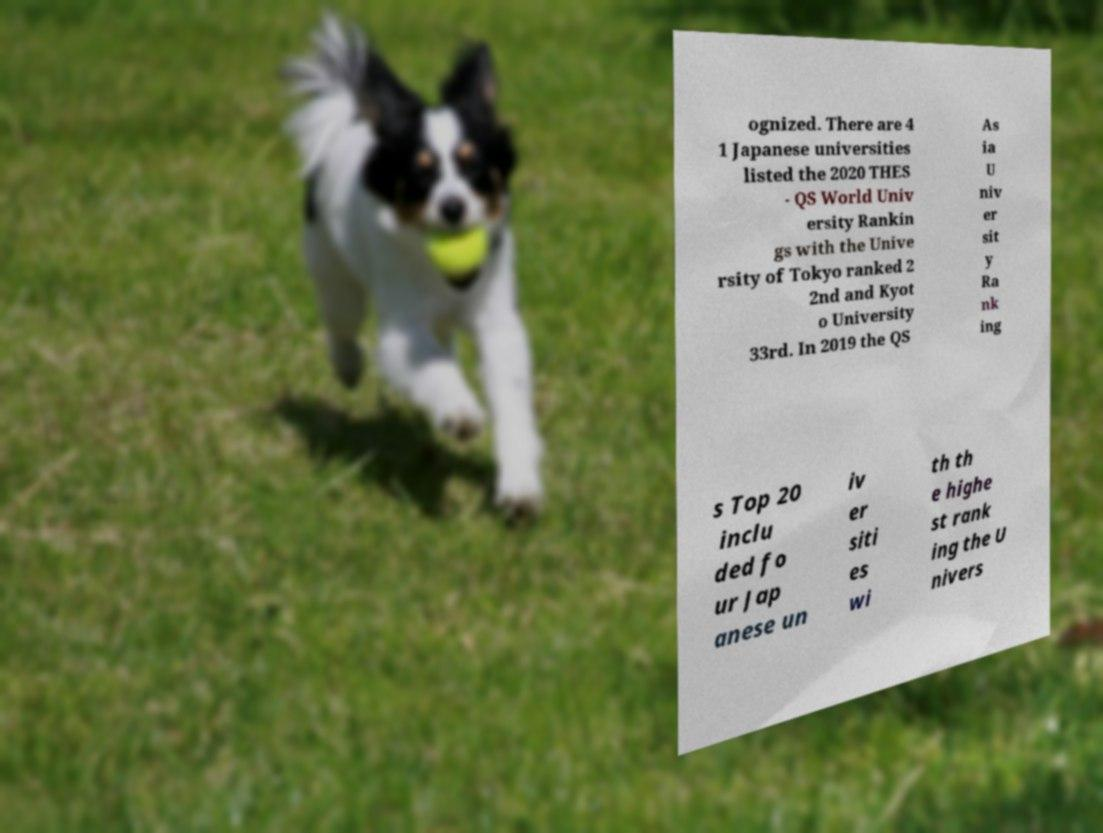What messages or text are displayed in this image? I need them in a readable, typed format. ognized. There are 4 1 Japanese universities listed the 2020 THES - QS World Univ ersity Rankin gs with the Unive rsity of Tokyo ranked 2 2nd and Kyot o University 33rd. In 2019 the QS As ia U niv er sit y Ra nk ing s Top 20 inclu ded fo ur Jap anese un iv er siti es wi th th e highe st rank ing the U nivers 